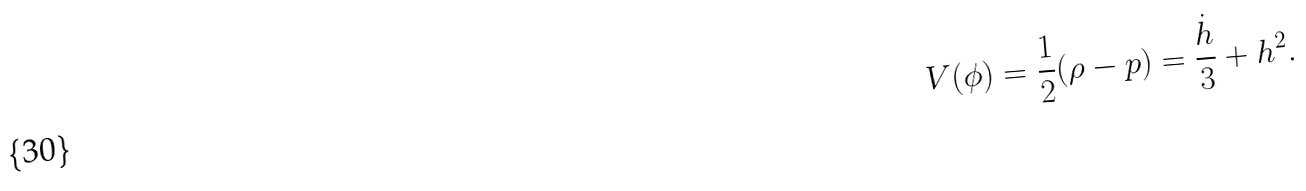<formula> <loc_0><loc_0><loc_500><loc_500>V ( \phi ) = \frac { 1 } { 2 } ( \rho - p ) = \frac { \dot { h } } { 3 } + h ^ { 2 } .</formula> 